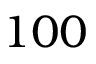<formula> <loc_0><loc_0><loc_500><loc_500>1 0 0</formula> 